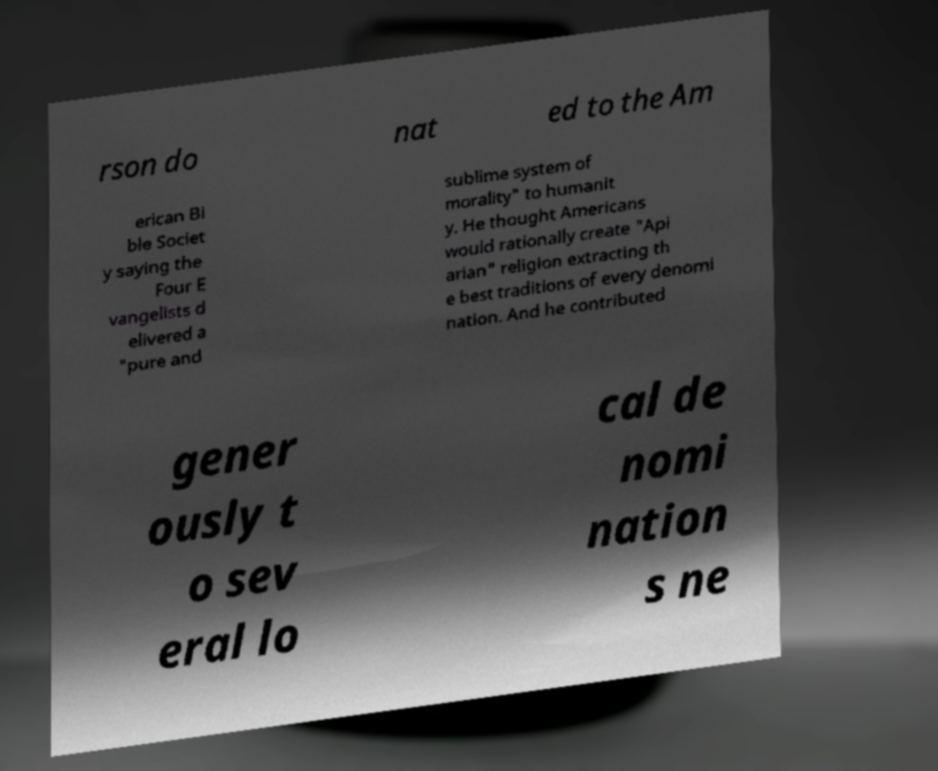Can you read and provide the text displayed in the image?This photo seems to have some interesting text. Can you extract and type it out for me? rson do nat ed to the Am erican Bi ble Societ y saying the Four E vangelists d elivered a "pure and sublime system of morality" to humanit y. He thought Americans would rationally create "Api arian" religion extracting th e best traditions of every denomi nation. And he contributed gener ously t o sev eral lo cal de nomi nation s ne 